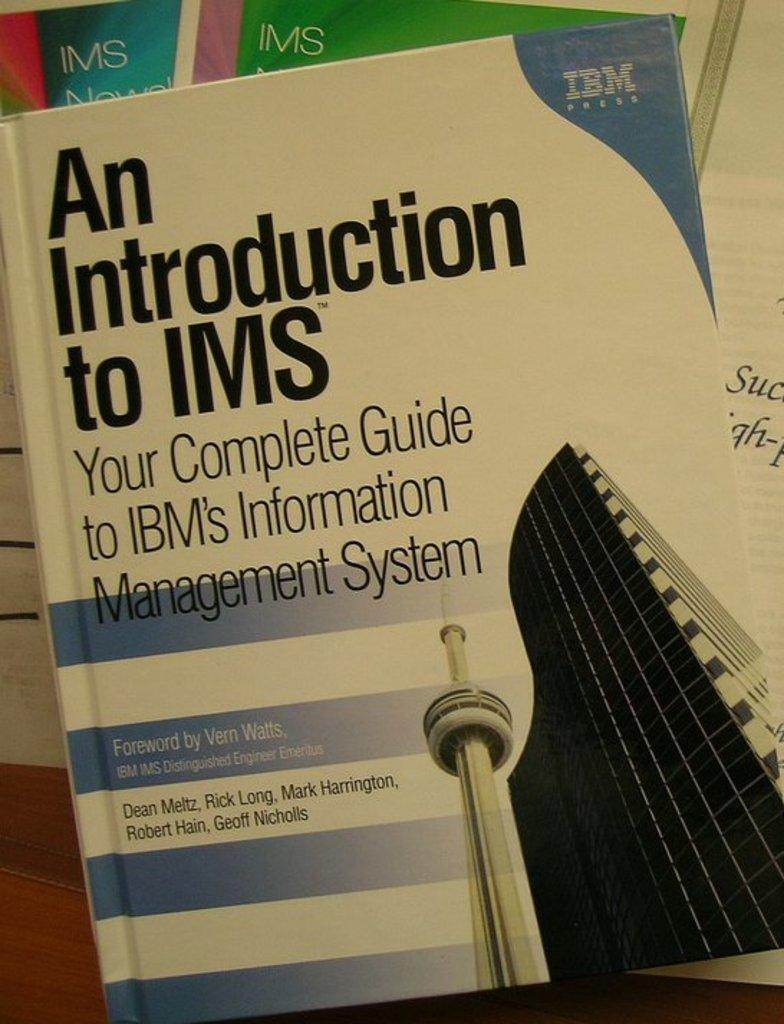<image>
Describe the image concisely. A textbook shows the IBM logo in one corner and a forward written by Vern Watts. 